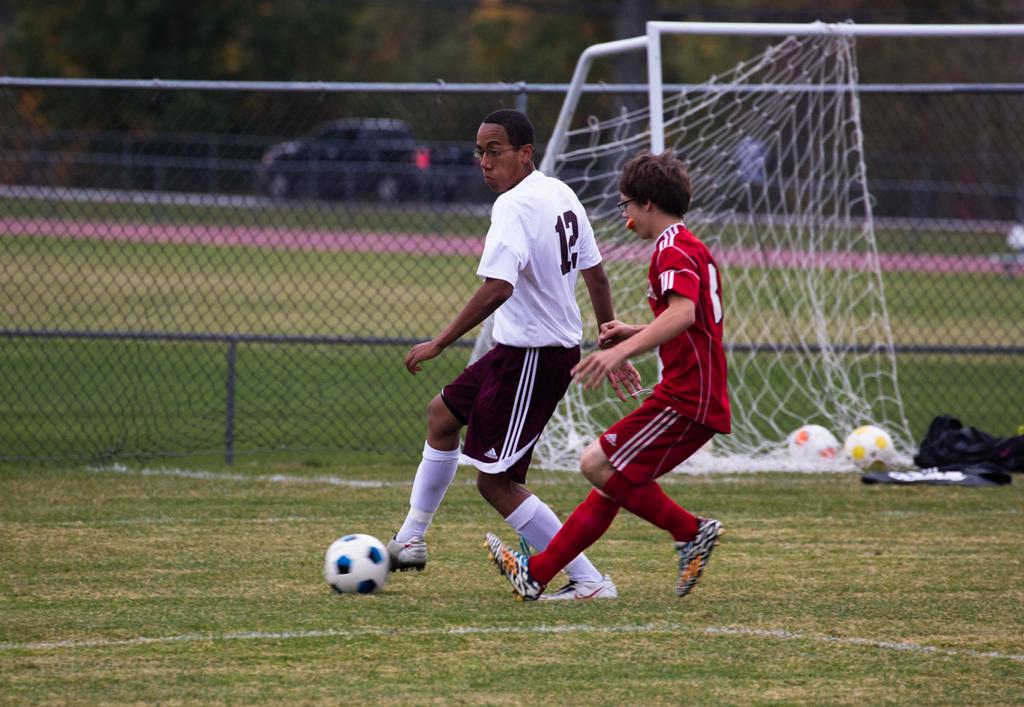What is the player in white's number?
Offer a very short reply. 12. What is the word on the bottom of their shorts in the triangle?
Offer a very short reply. Adidas. 